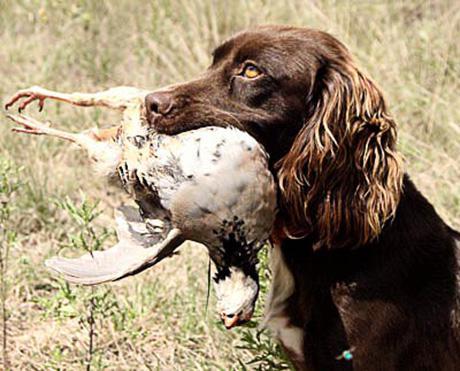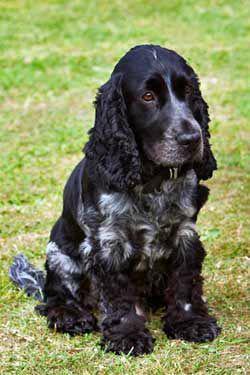The first image is the image on the left, the second image is the image on the right. Examine the images to the left and right. Is the description "An image contains a dog with a dead bird in its mouth." accurate? Answer yes or no. Yes. The first image is the image on the left, the second image is the image on the right. Examine the images to the left and right. Is the description "One image shows a black-and-gray spaniel sitting upright, and the other image shows a brown spaniel holding a game bird in its mouth." accurate? Answer yes or no. Yes. 